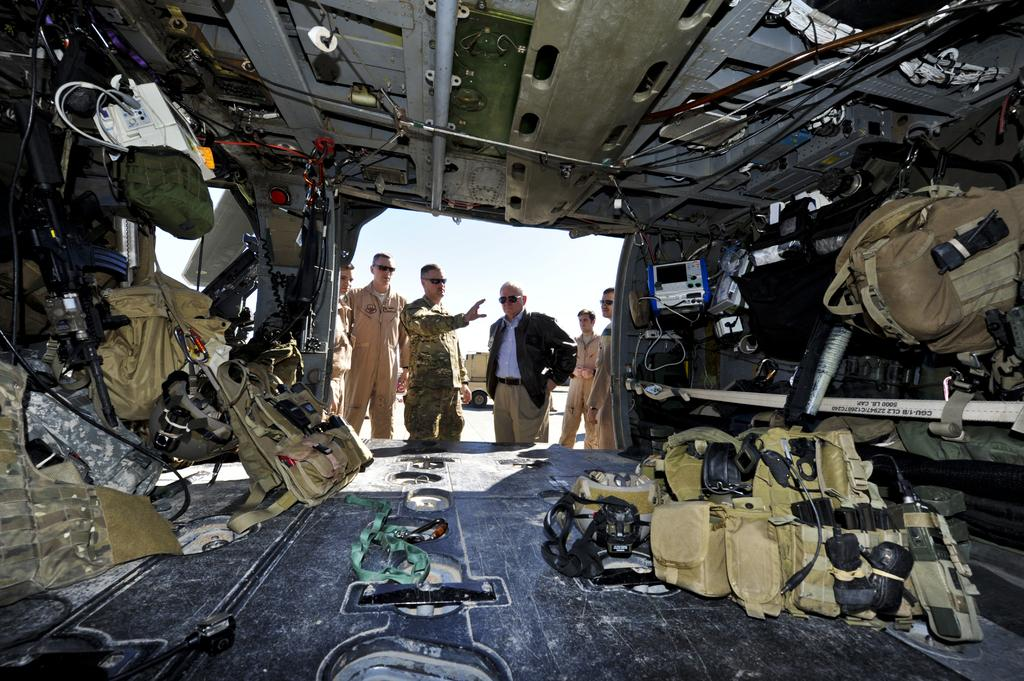What can be seen in the image in terms of human presence? There are people standing in the image. Where are the people standing? The people are standing on the floor. What else is visible in the image besides the people? There are bags and machines in the image. What type of texture can be felt on the cattle in the image? There are no cattle present in the image, so it is not possible to determine the texture of their skin. 